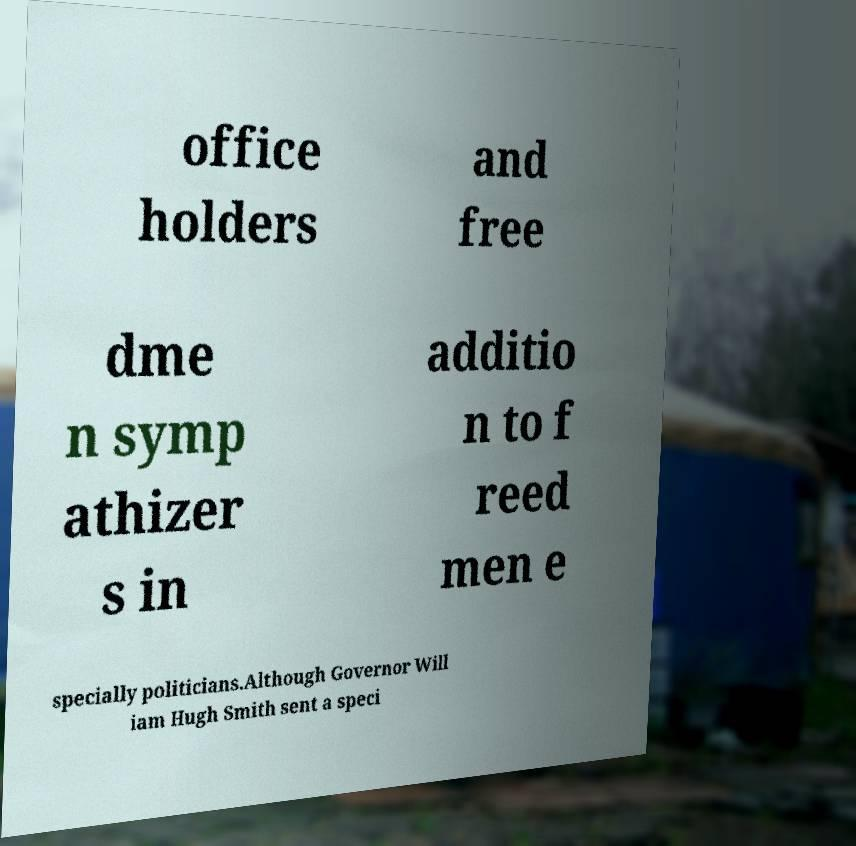Could you extract and type out the text from this image? office holders and free dme n symp athizer s in additio n to f reed men e specially politicians.Although Governor Will iam Hugh Smith sent a speci 